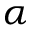<formula> <loc_0><loc_0><loc_500><loc_500>\alpha</formula> 